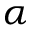<formula> <loc_0><loc_0><loc_500><loc_500>\alpha</formula> 